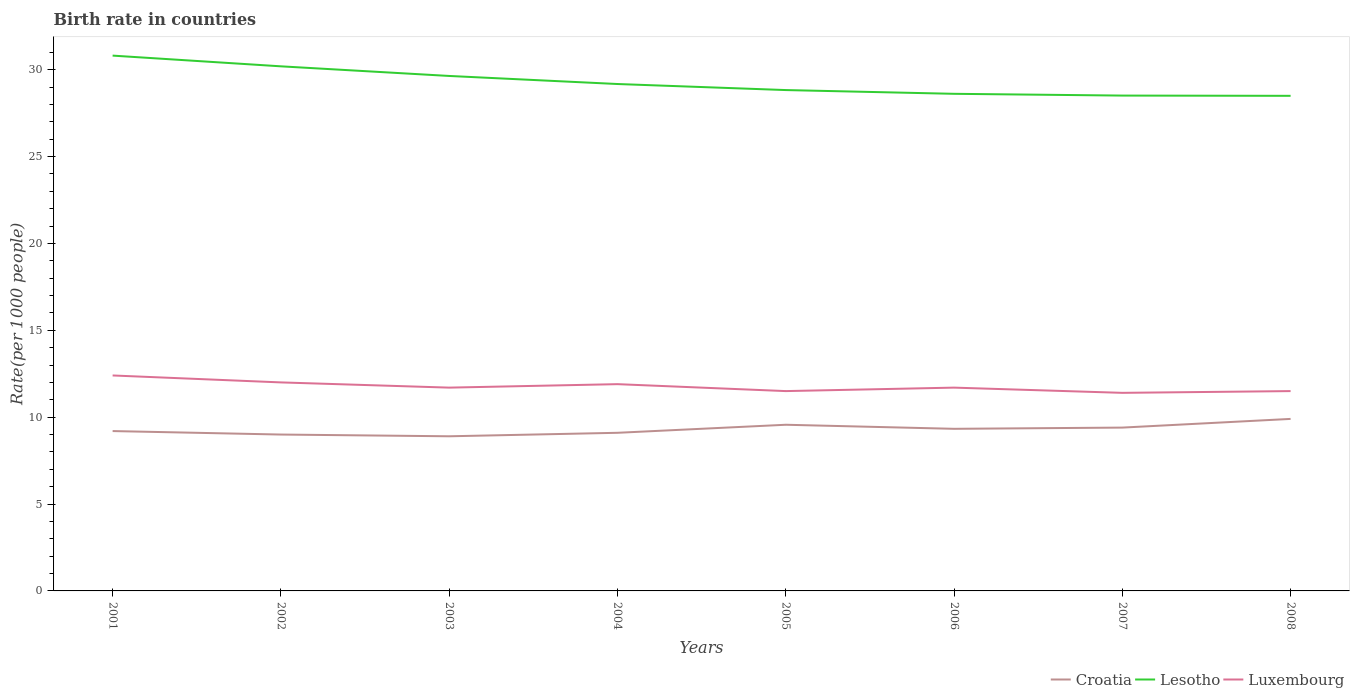Does the line corresponding to Lesotho intersect with the line corresponding to Croatia?
Your answer should be very brief. No. In which year was the birth rate in Croatia maximum?
Ensure brevity in your answer.  2003. What is the total birth rate in Luxembourg in the graph?
Ensure brevity in your answer.  0.9. What is the difference between the highest and the second highest birth rate in Luxembourg?
Ensure brevity in your answer.  1. Is the birth rate in Lesotho strictly greater than the birth rate in Luxembourg over the years?
Your answer should be very brief. No. How many lines are there?
Provide a short and direct response. 3. How many years are there in the graph?
Provide a short and direct response. 8. What is the difference between two consecutive major ticks on the Y-axis?
Ensure brevity in your answer.  5. Does the graph contain any zero values?
Offer a terse response. No. Does the graph contain grids?
Your answer should be very brief. No. Where does the legend appear in the graph?
Provide a short and direct response. Bottom right. How many legend labels are there?
Provide a short and direct response. 3. What is the title of the graph?
Your answer should be compact. Birth rate in countries. Does "Aruba" appear as one of the legend labels in the graph?
Provide a succinct answer. No. What is the label or title of the Y-axis?
Your response must be concise. Rate(per 1000 people). What is the Rate(per 1000 people) of Lesotho in 2001?
Your answer should be very brief. 30.81. What is the Rate(per 1000 people) of Luxembourg in 2001?
Provide a short and direct response. 12.4. What is the Rate(per 1000 people) of Croatia in 2002?
Offer a terse response. 9. What is the Rate(per 1000 people) of Lesotho in 2002?
Ensure brevity in your answer.  30.19. What is the Rate(per 1000 people) of Lesotho in 2003?
Your response must be concise. 29.64. What is the Rate(per 1000 people) in Luxembourg in 2003?
Keep it short and to the point. 11.7. What is the Rate(per 1000 people) in Croatia in 2004?
Your answer should be very brief. 9.1. What is the Rate(per 1000 people) in Lesotho in 2004?
Provide a succinct answer. 29.17. What is the Rate(per 1000 people) of Luxembourg in 2004?
Ensure brevity in your answer.  11.9. What is the Rate(per 1000 people) in Croatia in 2005?
Ensure brevity in your answer.  9.56. What is the Rate(per 1000 people) of Lesotho in 2005?
Your answer should be compact. 28.82. What is the Rate(per 1000 people) of Luxembourg in 2005?
Provide a short and direct response. 11.5. What is the Rate(per 1000 people) in Croatia in 2006?
Your response must be concise. 9.33. What is the Rate(per 1000 people) in Lesotho in 2006?
Your response must be concise. 28.61. What is the Rate(per 1000 people) of Luxembourg in 2006?
Make the answer very short. 11.7. What is the Rate(per 1000 people) in Croatia in 2007?
Make the answer very short. 9.4. What is the Rate(per 1000 people) of Lesotho in 2007?
Your response must be concise. 28.51. What is the Rate(per 1000 people) in Luxembourg in 2007?
Provide a short and direct response. 11.4. What is the Rate(per 1000 people) of Croatia in 2008?
Offer a very short reply. 9.9. What is the Rate(per 1000 people) of Lesotho in 2008?
Your answer should be very brief. 28.49. Across all years, what is the maximum Rate(per 1000 people) in Croatia?
Offer a very short reply. 9.9. Across all years, what is the maximum Rate(per 1000 people) of Lesotho?
Your answer should be compact. 30.81. Across all years, what is the maximum Rate(per 1000 people) of Luxembourg?
Offer a terse response. 12.4. Across all years, what is the minimum Rate(per 1000 people) of Croatia?
Provide a short and direct response. 8.9. Across all years, what is the minimum Rate(per 1000 people) in Lesotho?
Provide a succinct answer. 28.49. Across all years, what is the minimum Rate(per 1000 people) of Luxembourg?
Offer a terse response. 11.4. What is the total Rate(per 1000 people) of Croatia in the graph?
Your response must be concise. 74.39. What is the total Rate(per 1000 people) of Lesotho in the graph?
Give a very brief answer. 234.24. What is the total Rate(per 1000 people) in Luxembourg in the graph?
Offer a terse response. 94.1. What is the difference between the Rate(per 1000 people) of Croatia in 2001 and that in 2002?
Your response must be concise. 0.2. What is the difference between the Rate(per 1000 people) of Lesotho in 2001 and that in 2002?
Give a very brief answer. 0.62. What is the difference between the Rate(per 1000 people) of Croatia in 2001 and that in 2003?
Your answer should be compact. 0.3. What is the difference between the Rate(per 1000 people) in Lesotho in 2001 and that in 2003?
Your answer should be compact. 1.17. What is the difference between the Rate(per 1000 people) in Luxembourg in 2001 and that in 2003?
Provide a short and direct response. 0.7. What is the difference between the Rate(per 1000 people) in Croatia in 2001 and that in 2004?
Your answer should be very brief. 0.1. What is the difference between the Rate(per 1000 people) of Lesotho in 2001 and that in 2004?
Provide a short and direct response. 1.64. What is the difference between the Rate(per 1000 people) in Croatia in 2001 and that in 2005?
Provide a short and direct response. -0.36. What is the difference between the Rate(per 1000 people) in Lesotho in 2001 and that in 2005?
Offer a very short reply. 1.98. What is the difference between the Rate(per 1000 people) in Luxembourg in 2001 and that in 2005?
Ensure brevity in your answer.  0.9. What is the difference between the Rate(per 1000 people) of Croatia in 2001 and that in 2006?
Make the answer very short. -0.13. What is the difference between the Rate(per 1000 people) in Lesotho in 2001 and that in 2006?
Offer a terse response. 2.2. What is the difference between the Rate(per 1000 people) of Luxembourg in 2001 and that in 2006?
Your answer should be compact. 0.7. What is the difference between the Rate(per 1000 people) in Luxembourg in 2001 and that in 2007?
Offer a very short reply. 1. What is the difference between the Rate(per 1000 people) of Croatia in 2001 and that in 2008?
Offer a terse response. -0.7. What is the difference between the Rate(per 1000 people) in Lesotho in 2001 and that in 2008?
Offer a terse response. 2.31. What is the difference between the Rate(per 1000 people) in Lesotho in 2002 and that in 2003?
Give a very brief answer. 0.55. What is the difference between the Rate(per 1000 people) in Luxembourg in 2002 and that in 2003?
Your answer should be compact. 0.3. What is the difference between the Rate(per 1000 people) of Croatia in 2002 and that in 2004?
Ensure brevity in your answer.  -0.1. What is the difference between the Rate(per 1000 people) in Luxembourg in 2002 and that in 2004?
Give a very brief answer. 0.1. What is the difference between the Rate(per 1000 people) of Croatia in 2002 and that in 2005?
Provide a succinct answer. -0.56. What is the difference between the Rate(per 1000 people) in Lesotho in 2002 and that in 2005?
Your response must be concise. 1.37. What is the difference between the Rate(per 1000 people) of Croatia in 2002 and that in 2006?
Offer a terse response. -0.33. What is the difference between the Rate(per 1000 people) in Lesotho in 2002 and that in 2006?
Make the answer very short. 1.58. What is the difference between the Rate(per 1000 people) of Lesotho in 2002 and that in 2007?
Provide a short and direct response. 1.68. What is the difference between the Rate(per 1000 people) of Luxembourg in 2002 and that in 2007?
Ensure brevity in your answer.  0.6. What is the difference between the Rate(per 1000 people) in Lesotho in 2002 and that in 2008?
Make the answer very short. 1.7. What is the difference between the Rate(per 1000 people) in Croatia in 2003 and that in 2004?
Give a very brief answer. -0.2. What is the difference between the Rate(per 1000 people) of Lesotho in 2003 and that in 2004?
Your response must be concise. 0.46. What is the difference between the Rate(per 1000 people) of Luxembourg in 2003 and that in 2004?
Your answer should be very brief. -0.2. What is the difference between the Rate(per 1000 people) of Croatia in 2003 and that in 2005?
Offer a terse response. -0.66. What is the difference between the Rate(per 1000 people) in Lesotho in 2003 and that in 2005?
Make the answer very short. 0.81. What is the difference between the Rate(per 1000 people) in Croatia in 2003 and that in 2006?
Make the answer very short. -0.43. What is the difference between the Rate(per 1000 people) of Lesotho in 2003 and that in 2006?
Ensure brevity in your answer.  1.03. What is the difference between the Rate(per 1000 people) of Lesotho in 2003 and that in 2007?
Provide a succinct answer. 1.13. What is the difference between the Rate(per 1000 people) of Lesotho in 2003 and that in 2008?
Ensure brevity in your answer.  1.14. What is the difference between the Rate(per 1000 people) of Croatia in 2004 and that in 2005?
Keep it short and to the point. -0.46. What is the difference between the Rate(per 1000 people) in Lesotho in 2004 and that in 2005?
Provide a succinct answer. 0.35. What is the difference between the Rate(per 1000 people) of Croatia in 2004 and that in 2006?
Ensure brevity in your answer.  -0.23. What is the difference between the Rate(per 1000 people) in Lesotho in 2004 and that in 2006?
Offer a terse response. 0.56. What is the difference between the Rate(per 1000 people) of Croatia in 2004 and that in 2007?
Offer a terse response. -0.3. What is the difference between the Rate(per 1000 people) of Lesotho in 2004 and that in 2007?
Keep it short and to the point. 0.67. What is the difference between the Rate(per 1000 people) of Luxembourg in 2004 and that in 2007?
Your response must be concise. 0.5. What is the difference between the Rate(per 1000 people) in Lesotho in 2004 and that in 2008?
Give a very brief answer. 0.68. What is the difference between the Rate(per 1000 people) of Croatia in 2005 and that in 2006?
Ensure brevity in your answer.  0.23. What is the difference between the Rate(per 1000 people) in Lesotho in 2005 and that in 2006?
Your answer should be compact. 0.22. What is the difference between the Rate(per 1000 people) of Luxembourg in 2005 and that in 2006?
Your response must be concise. -0.2. What is the difference between the Rate(per 1000 people) of Croatia in 2005 and that in 2007?
Provide a short and direct response. 0.16. What is the difference between the Rate(per 1000 people) in Lesotho in 2005 and that in 2007?
Your answer should be compact. 0.32. What is the difference between the Rate(per 1000 people) of Luxembourg in 2005 and that in 2007?
Provide a succinct answer. 0.1. What is the difference between the Rate(per 1000 people) of Croatia in 2005 and that in 2008?
Make the answer very short. -0.34. What is the difference between the Rate(per 1000 people) in Lesotho in 2005 and that in 2008?
Your response must be concise. 0.33. What is the difference between the Rate(per 1000 people) of Luxembourg in 2005 and that in 2008?
Your answer should be compact. 0. What is the difference between the Rate(per 1000 people) in Croatia in 2006 and that in 2007?
Your response must be concise. -0.07. What is the difference between the Rate(per 1000 people) in Lesotho in 2006 and that in 2007?
Give a very brief answer. 0.1. What is the difference between the Rate(per 1000 people) in Croatia in 2006 and that in 2008?
Your answer should be compact. -0.57. What is the difference between the Rate(per 1000 people) of Lesotho in 2006 and that in 2008?
Offer a terse response. 0.12. What is the difference between the Rate(per 1000 people) of Croatia in 2007 and that in 2008?
Offer a very short reply. -0.5. What is the difference between the Rate(per 1000 people) in Lesotho in 2007 and that in 2008?
Provide a short and direct response. 0.01. What is the difference between the Rate(per 1000 people) in Croatia in 2001 and the Rate(per 1000 people) in Lesotho in 2002?
Your answer should be compact. -20.99. What is the difference between the Rate(per 1000 people) in Lesotho in 2001 and the Rate(per 1000 people) in Luxembourg in 2002?
Offer a very short reply. 18.81. What is the difference between the Rate(per 1000 people) in Croatia in 2001 and the Rate(per 1000 people) in Lesotho in 2003?
Give a very brief answer. -20.44. What is the difference between the Rate(per 1000 people) in Croatia in 2001 and the Rate(per 1000 people) in Luxembourg in 2003?
Give a very brief answer. -2.5. What is the difference between the Rate(per 1000 people) in Lesotho in 2001 and the Rate(per 1000 people) in Luxembourg in 2003?
Offer a terse response. 19.11. What is the difference between the Rate(per 1000 people) in Croatia in 2001 and the Rate(per 1000 people) in Lesotho in 2004?
Give a very brief answer. -19.97. What is the difference between the Rate(per 1000 people) in Croatia in 2001 and the Rate(per 1000 people) in Luxembourg in 2004?
Your response must be concise. -2.7. What is the difference between the Rate(per 1000 people) in Lesotho in 2001 and the Rate(per 1000 people) in Luxembourg in 2004?
Offer a terse response. 18.91. What is the difference between the Rate(per 1000 people) in Croatia in 2001 and the Rate(per 1000 people) in Lesotho in 2005?
Provide a short and direct response. -19.62. What is the difference between the Rate(per 1000 people) in Croatia in 2001 and the Rate(per 1000 people) in Luxembourg in 2005?
Ensure brevity in your answer.  -2.3. What is the difference between the Rate(per 1000 people) in Lesotho in 2001 and the Rate(per 1000 people) in Luxembourg in 2005?
Your response must be concise. 19.31. What is the difference between the Rate(per 1000 people) of Croatia in 2001 and the Rate(per 1000 people) of Lesotho in 2006?
Give a very brief answer. -19.41. What is the difference between the Rate(per 1000 people) in Croatia in 2001 and the Rate(per 1000 people) in Luxembourg in 2006?
Give a very brief answer. -2.5. What is the difference between the Rate(per 1000 people) in Lesotho in 2001 and the Rate(per 1000 people) in Luxembourg in 2006?
Ensure brevity in your answer.  19.11. What is the difference between the Rate(per 1000 people) of Croatia in 2001 and the Rate(per 1000 people) of Lesotho in 2007?
Your answer should be very brief. -19.31. What is the difference between the Rate(per 1000 people) of Lesotho in 2001 and the Rate(per 1000 people) of Luxembourg in 2007?
Make the answer very short. 19.41. What is the difference between the Rate(per 1000 people) of Croatia in 2001 and the Rate(per 1000 people) of Lesotho in 2008?
Make the answer very short. -19.29. What is the difference between the Rate(per 1000 people) in Lesotho in 2001 and the Rate(per 1000 people) in Luxembourg in 2008?
Ensure brevity in your answer.  19.31. What is the difference between the Rate(per 1000 people) in Croatia in 2002 and the Rate(per 1000 people) in Lesotho in 2003?
Offer a terse response. -20.64. What is the difference between the Rate(per 1000 people) of Croatia in 2002 and the Rate(per 1000 people) of Luxembourg in 2003?
Your response must be concise. -2.7. What is the difference between the Rate(per 1000 people) in Lesotho in 2002 and the Rate(per 1000 people) in Luxembourg in 2003?
Ensure brevity in your answer.  18.49. What is the difference between the Rate(per 1000 people) of Croatia in 2002 and the Rate(per 1000 people) of Lesotho in 2004?
Provide a succinct answer. -20.17. What is the difference between the Rate(per 1000 people) in Croatia in 2002 and the Rate(per 1000 people) in Luxembourg in 2004?
Offer a terse response. -2.9. What is the difference between the Rate(per 1000 people) in Lesotho in 2002 and the Rate(per 1000 people) in Luxembourg in 2004?
Ensure brevity in your answer.  18.29. What is the difference between the Rate(per 1000 people) in Croatia in 2002 and the Rate(per 1000 people) in Lesotho in 2005?
Offer a terse response. -19.82. What is the difference between the Rate(per 1000 people) of Lesotho in 2002 and the Rate(per 1000 people) of Luxembourg in 2005?
Offer a terse response. 18.69. What is the difference between the Rate(per 1000 people) of Croatia in 2002 and the Rate(per 1000 people) of Lesotho in 2006?
Your answer should be compact. -19.61. What is the difference between the Rate(per 1000 people) in Lesotho in 2002 and the Rate(per 1000 people) in Luxembourg in 2006?
Keep it short and to the point. 18.49. What is the difference between the Rate(per 1000 people) in Croatia in 2002 and the Rate(per 1000 people) in Lesotho in 2007?
Make the answer very short. -19.51. What is the difference between the Rate(per 1000 people) in Lesotho in 2002 and the Rate(per 1000 people) in Luxembourg in 2007?
Offer a terse response. 18.79. What is the difference between the Rate(per 1000 people) in Croatia in 2002 and the Rate(per 1000 people) in Lesotho in 2008?
Your response must be concise. -19.49. What is the difference between the Rate(per 1000 people) of Lesotho in 2002 and the Rate(per 1000 people) of Luxembourg in 2008?
Offer a terse response. 18.69. What is the difference between the Rate(per 1000 people) of Croatia in 2003 and the Rate(per 1000 people) of Lesotho in 2004?
Your answer should be compact. -20.27. What is the difference between the Rate(per 1000 people) of Lesotho in 2003 and the Rate(per 1000 people) of Luxembourg in 2004?
Give a very brief answer. 17.74. What is the difference between the Rate(per 1000 people) in Croatia in 2003 and the Rate(per 1000 people) in Lesotho in 2005?
Offer a terse response. -19.93. What is the difference between the Rate(per 1000 people) of Croatia in 2003 and the Rate(per 1000 people) of Luxembourg in 2005?
Your answer should be very brief. -2.6. What is the difference between the Rate(per 1000 people) of Lesotho in 2003 and the Rate(per 1000 people) of Luxembourg in 2005?
Make the answer very short. 18.14. What is the difference between the Rate(per 1000 people) in Croatia in 2003 and the Rate(per 1000 people) in Lesotho in 2006?
Provide a short and direct response. -19.71. What is the difference between the Rate(per 1000 people) of Lesotho in 2003 and the Rate(per 1000 people) of Luxembourg in 2006?
Give a very brief answer. 17.94. What is the difference between the Rate(per 1000 people) of Croatia in 2003 and the Rate(per 1000 people) of Lesotho in 2007?
Your response must be concise. -19.61. What is the difference between the Rate(per 1000 people) of Croatia in 2003 and the Rate(per 1000 people) of Luxembourg in 2007?
Offer a terse response. -2.5. What is the difference between the Rate(per 1000 people) of Lesotho in 2003 and the Rate(per 1000 people) of Luxembourg in 2007?
Give a very brief answer. 18.24. What is the difference between the Rate(per 1000 people) in Croatia in 2003 and the Rate(per 1000 people) in Lesotho in 2008?
Your answer should be very brief. -19.59. What is the difference between the Rate(per 1000 people) of Croatia in 2003 and the Rate(per 1000 people) of Luxembourg in 2008?
Provide a short and direct response. -2.6. What is the difference between the Rate(per 1000 people) in Lesotho in 2003 and the Rate(per 1000 people) in Luxembourg in 2008?
Your answer should be very brief. 18.14. What is the difference between the Rate(per 1000 people) of Croatia in 2004 and the Rate(per 1000 people) of Lesotho in 2005?
Offer a very short reply. -19.73. What is the difference between the Rate(per 1000 people) in Croatia in 2004 and the Rate(per 1000 people) in Luxembourg in 2005?
Provide a succinct answer. -2.4. What is the difference between the Rate(per 1000 people) of Lesotho in 2004 and the Rate(per 1000 people) of Luxembourg in 2005?
Your answer should be compact. 17.67. What is the difference between the Rate(per 1000 people) in Croatia in 2004 and the Rate(per 1000 people) in Lesotho in 2006?
Give a very brief answer. -19.51. What is the difference between the Rate(per 1000 people) in Lesotho in 2004 and the Rate(per 1000 people) in Luxembourg in 2006?
Offer a very short reply. 17.47. What is the difference between the Rate(per 1000 people) in Croatia in 2004 and the Rate(per 1000 people) in Lesotho in 2007?
Your answer should be very brief. -19.41. What is the difference between the Rate(per 1000 people) of Lesotho in 2004 and the Rate(per 1000 people) of Luxembourg in 2007?
Ensure brevity in your answer.  17.77. What is the difference between the Rate(per 1000 people) of Croatia in 2004 and the Rate(per 1000 people) of Lesotho in 2008?
Keep it short and to the point. -19.39. What is the difference between the Rate(per 1000 people) in Lesotho in 2004 and the Rate(per 1000 people) in Luxembourg in 2008?
Provide a short and direct response. 17.67. What is the difference between the Rate(per 1000 people) in Croatia in 2005 and the Rate(per 1000 people) in Lesotho in 2006?
Provide a succinct answer. -19.05. What is the difference between the Rate(per 1000 people) of Croatia in 2005 and the Rate(per 1000 people) of Luxembourg in 2006?
Offer a terse response. -2.14. What is the difference between the Rate(per 1000 people) of Lesotho in 2005 and the Rate(per 1000 people) of Luxembourg in 2006?
Make the answer very short. 17.12. What is the difference between the Rate(per 1000 people) of Croatia in 2005 and the Rate(per 1000 people) of Lesotho in 2007?
Provide a succinct answer. -18.95. What is the difference between the Rate(per 1000 people) of Croatia in 2005 and the Rate(per 1000 people) of Luxembourg in 2007?
Keep it short and to the point. -1.84. What is the difference between the Rate(per 1000 people) in Lesotho in 2005 and the Rate(per 1000 people) in Luxembourg in 2007?
Your response must be concise. 17.43. What is the difference between the Rate(per 1000 people) in Croatia in 2005 and the Rate(per 1000 people) in Lesotho in 2008?
Provide a succinct answer. -18.93. What is the difference between the Rate(per 1000 people) in Croatia in 2005 and the Rate(per 1000 people) in Luxembourg in 2008?
Your answer should be compact. -1.94. What is the difference between the Rate(per 1000 people) in Lesotho in 2005 and the Rate(per 1000 people) in Luxembourg in 2008?
Provide a succinct answer. 17.32. What is the difference between the Rate(per 1000 people) in Croatia in 2006 and the Rate(per 1000 people) in Lesotho in 2007?
Make the answer very short. -19.18. What is the difference between the Rate(per 1000 people) of Croatia in 2006 and the Rate(per 1000 people) of Luxembourg in 2007?
Your answer should be very brief. -2.07. What is the difference between the Rate(per 1000 people) in Lesotho in 2006 and the Rate(per 1000 people) in Luxembourg in 2007?
Your answer should be compact. 17.21. What is the difference between the Rate(per 1000 people) in Croatia in 2006 and the Rate(per 1000 people) in Lesotho in 2008?
Ensure brevity in your answer.  -19.16. What is the difference between the Rate(per 1000 people) of Croatia in 2006 and the Rate(per 1000 people) of Luxembourg in 2008?
Provide a succinct answer. -2.17. What is the difference between the Rate(per 1000 people) of Lesotho in 2006 and the Rate(per 1000 people) of Luxembourg in 2008?
Provide a succinct answer. 17.11. What is the difference between the Rate(per 1000 people) in Croatia in 2007 and the Rate(per 1000 people) in Lesotho in 2008?
Ensure brevity in your answer.  -19.09. What is the difference between the Rate(per 1000 people) of Lesotho in 2007 and the Rate(per 1000 people) of Luxembourg in 2008?
Provide a short and direct response. 17.01. What is the average Rate(per 1000 people) in Croatia per year?
Make the answer very short. 9.3. What is the average Rate(per 1000 people) in Lesotho per year?
Your answer should be compact. 29.28. What is the average Rate(per 1000 people) of Luxembourg per year?
Your response must be concise. 11.76. In the year 2001, what is the difference between the Rate(per 1000 people) of Croatia and Rate(per 1000 people) of Lesotho?
Your answer should be compact. -21.61. In the year 2001, what is the difference between the Rate(per 1000 people) of Croatia and Rate(per 1000 people) of Luxembourg?
Give a very brief answer. -3.2. In the year 2001, what is the difference between the Rate(per 1000 people) of Lesotho and Rate(per 1000 people) of Luxembourg?
Provide a short and direct response. 18.41. In the year 2002, what is the difference between the Rate(per 1000 people) in Croatia and Rate(per 1000 people) in Lesotho?
Your response must be concise. -21.19. In the year 2002, what is the difference between the Rate(per 1000 people) in Lesotho and Rate(per 1000 people) in Luxembourg?
Offer a terse response. 18.19. In the year 2003, what is the difference between the Rate(per 1000 people) in Croatia and Rate(per 1000 people) in Lesotho?
Keep it short and to the point. -20.74. In the year 2003, what is the difference between the Rate(per 1000 people) in Lesotho and Rate(per 1000 people) in Luxembourg?
Give a very brief answer. 17.94. In the year 2004, what is the difference between the Rate(per 1000 people) of Croatia and Rate(per 1000 people) of Lesotho?
Keep it short and to the point. -20.07. In the year 2004, what is the difference between the Rate(per 1000 people) in Lesotho and Rate(per 1000 people) in Luxembourg?
Provide a short and direct response. 17.27. In the year 2005, what is the difference between the Rate(per 1000 people) of Croatia and Rate(per 1000 people) of Lesotho?
Offer a terse response. -19.26. In the year 2005, what is the difference between the Rate(per 1000 people) in Croatia and Rate(per 1000 people) in Luxembourg?
Give a very brief answer. -1.94. In the year 2005, what is the difference between the Rate(per 1000 people) of Lesotho and Rate(per 1000 people) of Luxembourg?
Your response must be concise. 17.32. In the year 2006, what is the difference between the Rate(per 1000 people) of Croatia and Rate(per 1000 people) of Lesotho?
Your response must be concise. -19.28. In the year 2006, what is the difference between the Rate(per 1000 people) in Croatia and Rate(per 1000 people) in Luxembourg?
Provide a short and direct response. -2.37. In the year 2006, what is the difference between the Rate(per 1000 people) in Lesotho and Rate(per 1000 people) in Luxembourg?
Ensure brevity in your answer.  16.91. In the year 2007, what is the difference between the Rate(per 1000 people) of Croatia and Rate(per 1000 people) of Lesotho?
Make the answer very short. -19.11. In the year 2007, what is the difference between the Rate(per 1000 people) of Croatia and Rate(per 1000 people) of Luxembourg?
Provide a short and direct response. -2. In the year 2007, what is the difference between the Rate(per 1000 people) in Lesotho and Rate(per 1000 people) in Luxembourg?
Ensure brevity in your answer.  17.11. In the year 2008, what is the difference between the Rate(per 1000 people) in Croatia and Rate(per 1000 people) in Lesotho?
Provide a succinct answer. -18.59. In the year 2008, what is the difference between the Rate(per 1000 people) of Lesotho and Rate(per 1000 people) of Luxembourg?
Give a very brief answer. 16.99. What is the ratio of the Rate(per 1000 people) of Croatia in 2001 to that in 2002?
Keep it short and to the point. 1.02. What is the ratio of the Rate(per 1000 people) of Lesotho in 2001 to that in 2002?
Offer a very short reply. 1.02. What is the ratio of the Rate(per 1000 people) of Luxembourg in 2001 to that in 2002?
Keep it short and to the point. 1.03. What is the ratio of the Rate(per 1000 people) of Croatia in 2001 to that in 2003?
Provide a succinct answer. 1.03. What is the ratio of the Rate(per 1000 people) of Lesotho in 2001 to that in 2003?
Offer a very short reply. 1.04. What is the ratio of the Rate(per 1000 people) of Luxembourg in 2001 to that in 2003?
Ensure brevity in your answer.  1.06. What is the ratio of the Rate(per 1000 people) in Lesotho in 2001 to that in 2004?
Your answer should be compact. 1.06. What is the ratio of the Rate(per 1000 people) in Luxembourg in 2001 to that in 2004?
Provide a short and direct response. 1.04. What is the ratio of the Rate(per 1000 people) of Croatia in 2001 to that in 2005?
Your answer should be compact. 0.96. What is the ratio of the Rate(per 1000 people) in Lesotho in 2001 to that in 2005?
Keep it short and to the point. 1.07. What is the ratio of the Rate(per 1000 people) of Luxembourg in 2001 to that in 2005?
Your response must be concise. 1.08. What is the ratio of the Rate(per 1000 people) of Croatia in 2001 to that in 2006?
Provide a short and direct response. 0.99. What is the ratio of the Rate(per 1000 people) of Lesotho in 2001 to that in 2006?
Keep it short and to the point. 1.08. What is the ratio of the Rate(per 1000 people) of Luxembourg in 2001 to that in 2006?
Your answer should be very brief. 1.06. What is the ratio of the Rate(per 1000 people) in Croatia in 2001 to that in 2007?
Keep it short and to the point. 0.98. What is the ratio of the Rate(per 1000 people) of Lesotho in 2001 to that in 2007?
Keep it short and to the point. 1.08. What is the ratio of the Rate(per 1000 people) of Luxembourg in 2001 to that in 2007?
Your response must be concise. 1.09. What is the ratio of the Rate(per 1000 people) of Croatia in 2001 to that in 2008?
Keep it short and to the point. 0.93. What is the ratio of the Rate(per 1000 people) of Lesotho in 2001 to that in 2008?
Provide a short and direct response. 1.08. What is the ratio of the Rate(per 1000 people) of Luxembourg in 2001 to that in 2008?
Offer a very short reply. 1.08. What is the ratio of the Rate(per 1000 people) of Croatia in 2002 to that in 2003?
Provide a short and direct response. 1.01. What is the ratio of the Rate(per 1000 people) of Lesotho in 2002 to that in 2003?
Provide a short and direct response. 1.02. What is the ratio of the Rate(per 1000 people) in Luxembourg in 2002 to that in 2003?
Provide a succinct answer. 1.03. What is the ratio of the Rate(per 1000 people) in Croatia in 2002 to that in 2004?
Ensure brevity in your answer.  0.99. What is the ratio of the Rate(per 1000 people) in Lesotho in 2002 to that in 2004?
Your answer should be compact. 1.03. What is the ratio of the Rate(per 1000 people) in Luxembourg in 2002 to that in 2004?
Provide a succinct answer. 1.01. What is the ratio of the Rate(per 1000 people) of Croatia in 2002 to that in 2005?
Your answer should be very brief. 0.94. What is the ratio of the Rate(per 1000 people) of Lesotho in 2002 to that in 2005?
Give a very brief answer. 1.05. What is the ratio of the Rate(per 1000 people) in Luxembourg in 2002 to that in 2005?
Ensure brevity in your answer.  1.04. What is the ratio of the Rate(per 1000 people) of Croatia in 2002 to that in 2006?
Provide a short and direct response. 0.96. What is the ratio of the Rate(per 1000 people) of Lesotho in 2002 to that in 2006?
Your response must be concise. 1.06. What is the ratio of the Rate(per 1000 people) in Luxembourg in 2002 to that in 2006?
Your answer should be very brief. 1.03. What is the ratio of the Rate(per 1000 people) of Croatia in 2002 to that in 2007?
Your response must be concise. 0.96. What is the ratio of the Rate(per 1000 people) of Lesotho in 2002 to that in 2007?
Provide a succinct answer. 1.06. What is the ratio of the Rate(per 1000 people) in Luxembourg in 2002 to that in 2007?
Provide a succinct answer. 1.05. What is the ratio of the Rate(per 1000 people) of Croatia in 2002 to that in 2008?
Provide a short and direct response. 0.91. What is the ratio of the Rate(per 1000 people) in Lesotho in 2002 to that in 2008?
Your answer should be compact. 1.06. What is the ratio of the Rate(per 1000 people) of Luxembourg in 2002 to that in 2008?
Provide a succinct answer. 1.04. What is the ratio of the Rate(per 1000 people) in Lesotho in 2003 to that in 2004?
Your answer should be compact. 1.02. What is the ratio of the Rate(per 1000 people) of Luxembourg in 2003 to that in 2004?
Your answer should be compact. 0.98. What is the ratio of the Rate(per 1000 people) in Croatia in 2003 to that in 2005?
Provide a succinct answer. 0.93. What is the ratio of the Rate(per 1000 people) in Lesotho in 2003 to that in 2005?
Give a very brief answer. 1.03. What is the ratio of the Rate(per 1000 people) of Luxembourg in 2003 to that in 2005?
Your answer should be compact. 1.02. What is the ratio of the Rate(per 1000 people) in Croatia in 2003 to that in 2006?
Make the answer very short. 0.95. What is the ratio of the Rate(per 1000 people) of Lesotho in 2003 to that in 2006?
Your answer should be compact. 1.04. What is the ratio of the Rate(per 1000 people) in Luxembourg in 2003 to that in 2006?
Ensure brevity in your answer.  1. What is the ratio of the Rate(per 1000 people) of Croatia in 2003 to that in 2007?
Provide a short and direct response. 0.95. What is the ratio of the Rate(per 1000 people) of Lesotho in 2003 to that in 2007?
Offer a terse response. 1.04. What is the ratio of the Rate(per 1000 people) in Luxembourg in 2003 to that in 2007?
Ensure brevity in your answer.  1.03. What is the ratio of the Rate(per 1000 people) of Croatia in 2003 to that in 2008?
Ensure brevity in your answer.  0.9. What is the ratio of the Rate(per 1000 people) in Lesotho in 2003 to that in 2008?
Keep it short and to the point. 1.04. What is the ratio of the Rate(per 1000 people) in Luxembourg in 2003 to that in 2008?
Your answer should be very brief. 1.02. What is the ratio of the Rate(per 1000 people) in Croatia in 2004 to that in 2005?
Your response must be concise. 0.95. What is the ratio of the Rate(per 1000 people) in Lesotho in 2004 to that in 2005?
Provide a short and direct response. 1.01. What is the ratio of the Rate(per 1000 people) in Luxembourg in 2004 to that in 2005?
Your answer should be very brief. 1.03. What is the ratio of the Rate(per 1000 people) of Croatia in 2004 to that in 2006?
Keep it short and to the point. 0.98. What is the ratio of the Rate(per 1000 people) in Lesotho in 2004 to that in 2006?
Give a very brief answer. 1.02. What is the ratio of the Rate(per 1000 people) in Luxembourg in 2004 to that in 2006?
Make the answer very short. 1.02. What is the ratio of the Rate(per 1000 people) in Croatia in 2004 to that in 2007?
Make the answer very short. 0.97. What is the ratio of the Rate(per 1000 people) of Lesotho in 2004 to that in 2007?
Keep it short and to the point. 1.02. What is the ratio of the Rate(per 1000 people) in Luxembourg in 2004 to that in 2007?
Offer a terse response. 1.04. What is the ratio of the Rate(per 1000 people) in Croatia in 2004 to that in 2008?
Your answer should be compact. 0.92. What is the ratio of the Rate(per 1000 people) in Lesotho in 2004 to that in 2008?
Offer a very short reply. 1.02. What is the ratio of the Rate(per 1000 people) in Luxembourg in 2004 to that in 2008?
Ensure brevity in your answer.  1.03. What is the ratio of the Rate(per 1000 people) in Lesotho in 2005 to that in 2006?
Your answer should be very brief. 1.01. What is the ratio of the Rate(per 1000 people) of Luxembourg in 2005 to that in 2006?
Give a very brief answer. 0.98. What is the ratio of the Rate(per 1000 people) of Croatia in 2005 to that in 2007?
Offer a terse response. 1.02. What is the ratio of the Rate(per 1000 people) of Lesotho in 2005 to that in 2007?
Ensure brevity in your answer.  1.01. What is the ratio of the Rate(per 1000 people) of Luxembourg in 2005 to that in 2007?
Your response must be concise. 1.01. What is the ratio of the Rate(per 1000 people) in Lesotho in 2005 to that in 2008?
Your response must be concise. 1.01. What is the ratio of the Rate(per 1000 people) of Luxembourg in 2005 to that in 2008?
Offer a terse response. 1. What is the ratio of the Rate(per 1000 people) in Croatia in 2006 to that in 2007?
Ensure brevity in your answer.  0.99. What is the ratio of the Rate(per 1000 people) in Luxembourg in 2006 to that in 2007?
Provide a short and direct response. 1.03. What is the ratio of the Rate(per 1000 people) in Croatia in 2006 to that in 2008?
Make the answer very short. 0.94. What is the ratio of the Rate(per 1000 people) in Lesotho in 2006 to that in 2008?
Make the answer very short. 1. What is the ratio of the Rate(per 1000 people) of Luxembourg in 2006 to that in 2008?
Offer a very short reply. 1.02. What is the ratio of the Rate(per 1000 people) of Croatia in 2007 to that in 2008?
Make the answer very short. 0.95. What is the difference between the highest and the second highest Rate(per 1000 people) in Croatia?
Your answer should be compact. 0.34. What is the difference between the highest and the second highest Rate(per 1000 people) of Lesotho?
Give a very brief answer. 0.62. What is the difference between the highest and the second highest Rate(per 1000 people) of Luxembourg?
Provide a short and direct response. 0.4. What is the difference between the highest and the lowest Rate(per 1000 people) of Croatia?
Ensure brevity in your answer.  1. What is the difference between the highest and the lowest Rate(per 1000 people) of Lesotho?
Provide a succinct answer. 2.31. 